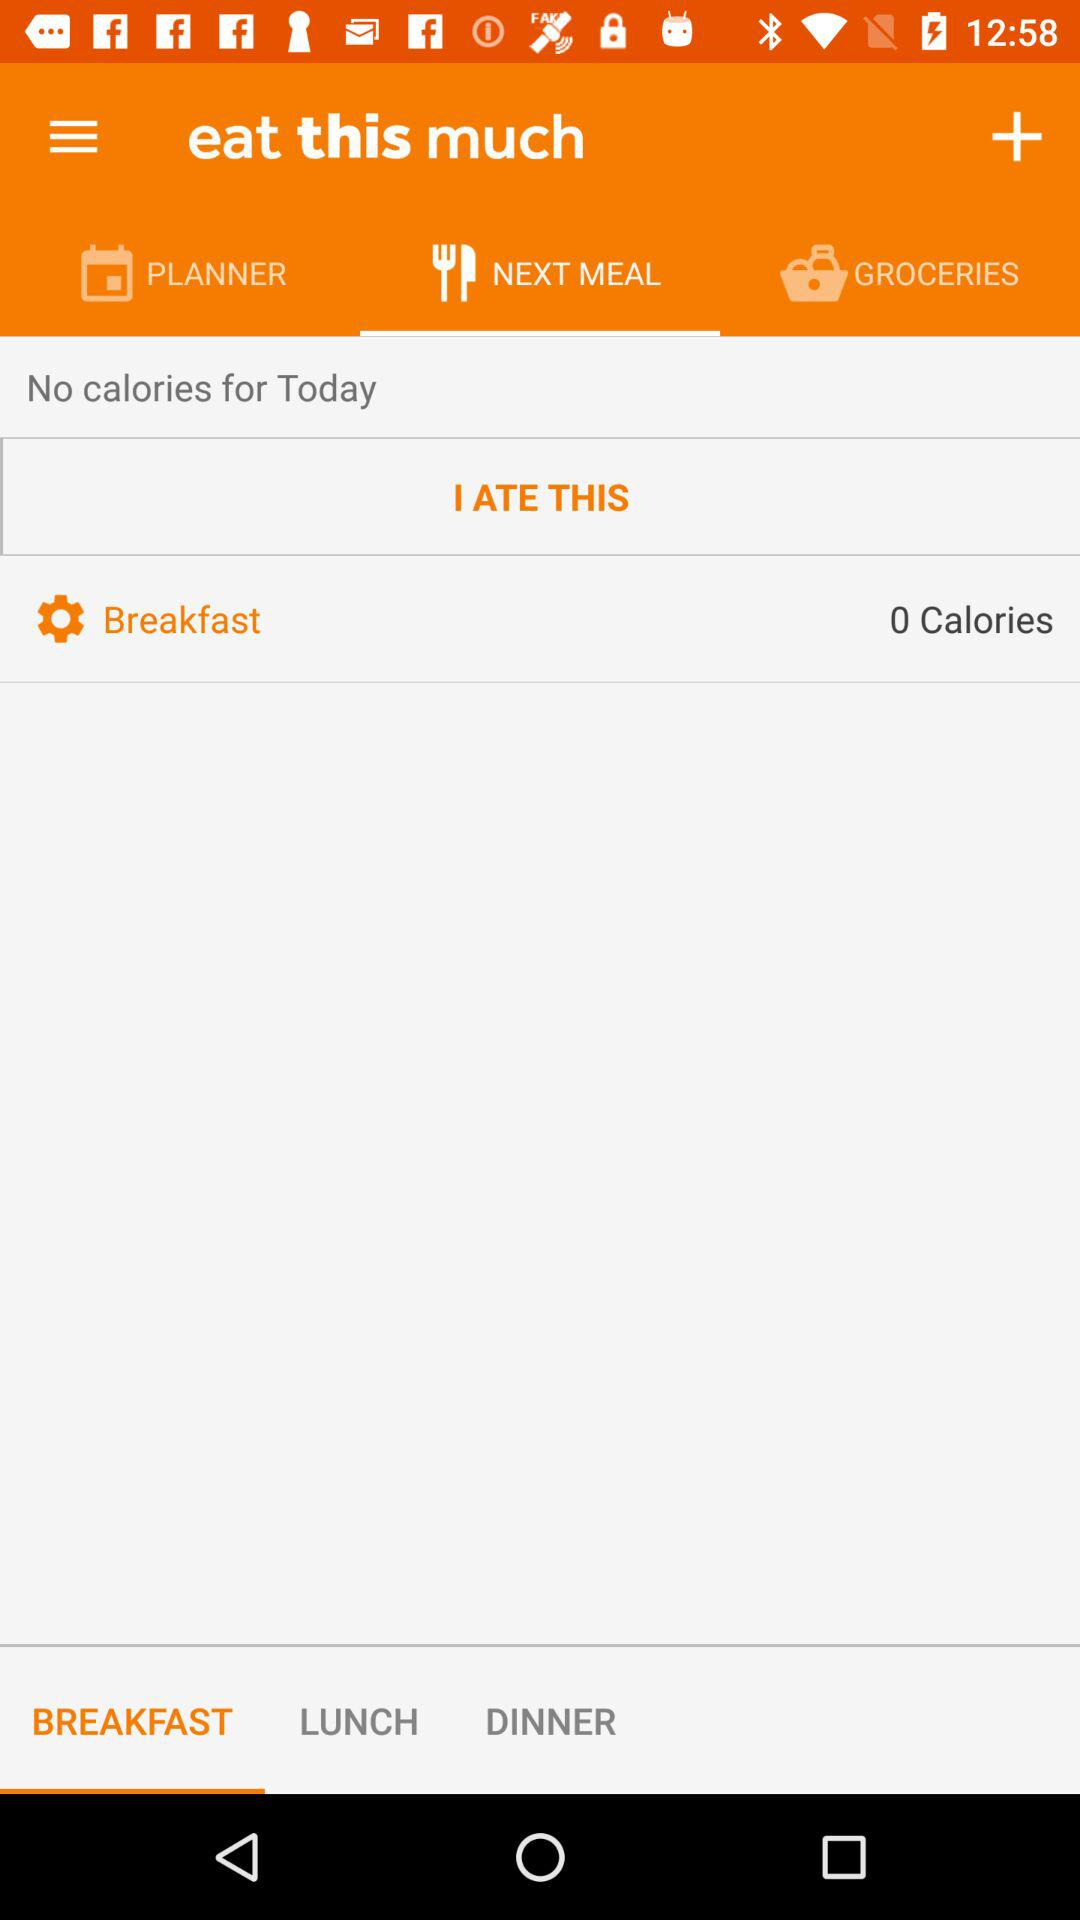What is the total number of calories consumed today?
Answer the question using a single word or phrase. 0 